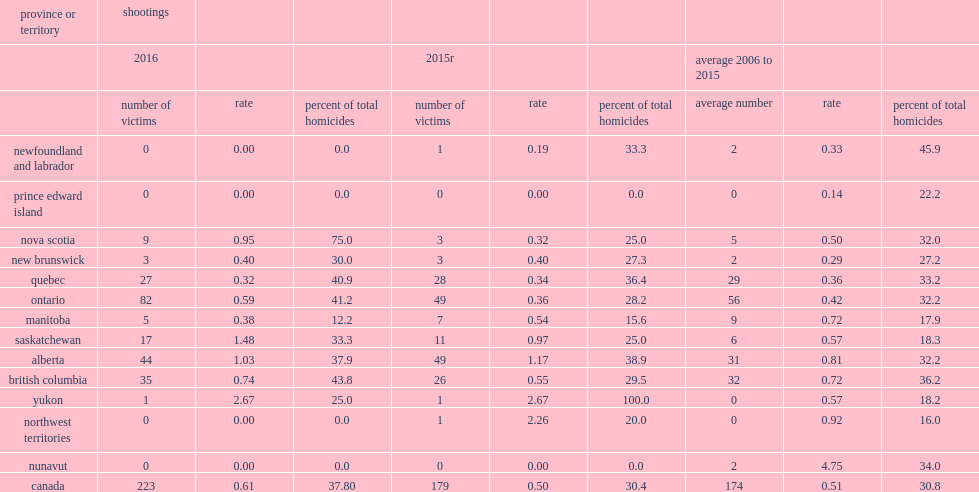I'm looking to parse the entire table for insights. Could you assist me with that? {'header': ['province or territory', 'shootings', '', '', '', '', '', '', '', ''], 'rows': [['', '2016', '', '', '2015r', '', '', 'average 2006 to 2015', '', ''], ['', 'number of victims', 'rate', 'percent of total homicides', 'number of victims', 'rate', 'percent of total homicides', 'average number', 'rate', 'percent of total homicides'], ['newfoundland and labrador', '0', '0.00', '0.0', '1', '0.19', '33.3', '2', '0.33', '45.9'], ['prince edward island', '0', '0.00', '0.0', '0', '0.00', '0.0', '0', '0.14', '22.2'], ['nova scotia', '9', '0.95', '75.0', '3', '0.32', '25.0', '5', '0.50', '32.0'], ['new brunswick', '3', '0.40', '30.0', '3', '0.40', '27.3', '2', '0.29', '27.2'], ['quebec', '27', '0.32', '40.9', '28', '0.34', '36.4', '29', '0.36', '33.2'], ['ontario', '82', '0.59', '41.2', '49', '0.36', '28.2', '56', '0.42', '32.2'], ['manitoba', '5', '0.38', '12.2', '7', '0.54', '15.6', '9', '0.72', '17.9'], ['saskatchewan', '17', '1.48', '33.3', '11', '0.97', '25.0', '6', '0.57', '18.3'], ['alberta', '44', '1.03', '37.9', '49', '1.17', '38.9', '31', '0.81', '32.2'], ['british columbia', '35', '0.74', '43.8', '26', '0.55', '29.5', '32', '0.72', '36.2'], ['yukon', '1', '2.67', '25.0', '1', '2.67', '100.0', '0', '0.57', '18.2'], ['northwest territories', '0', '0.00', '0.0', '1', '2.26', '20.0', '0', '0.92', '16.0'], ['nunavut', '0', '0.00', '0.0', '0', '0.00', '0.0', '2', '4.75', '34.0'], ['canada', '223', '0.61', '37.80', '179', '0.50', '30.4', '174', '0.51', '30.8']]} What was the difference in the rate of homicides by shooting in 2016 and the average for the previous 10 years? 0.1. 